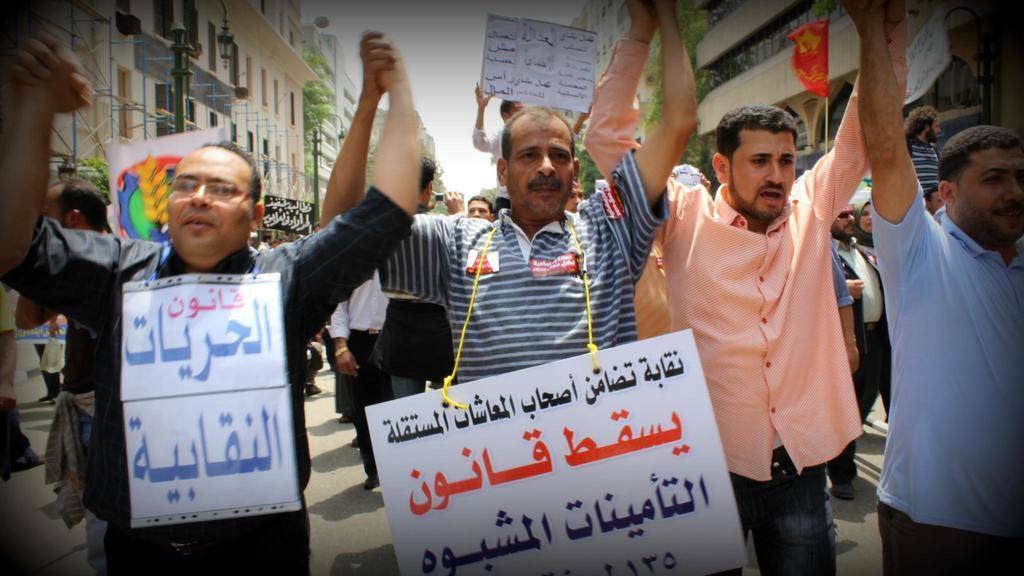Could you give a brief overview of what you see in this image? In this image I can see group of people standing, the person in front is wearing a white color board. Background I can see few multi color flags, buildings in white and cream color, few light poles, trees in green color and the sky is in white color. 